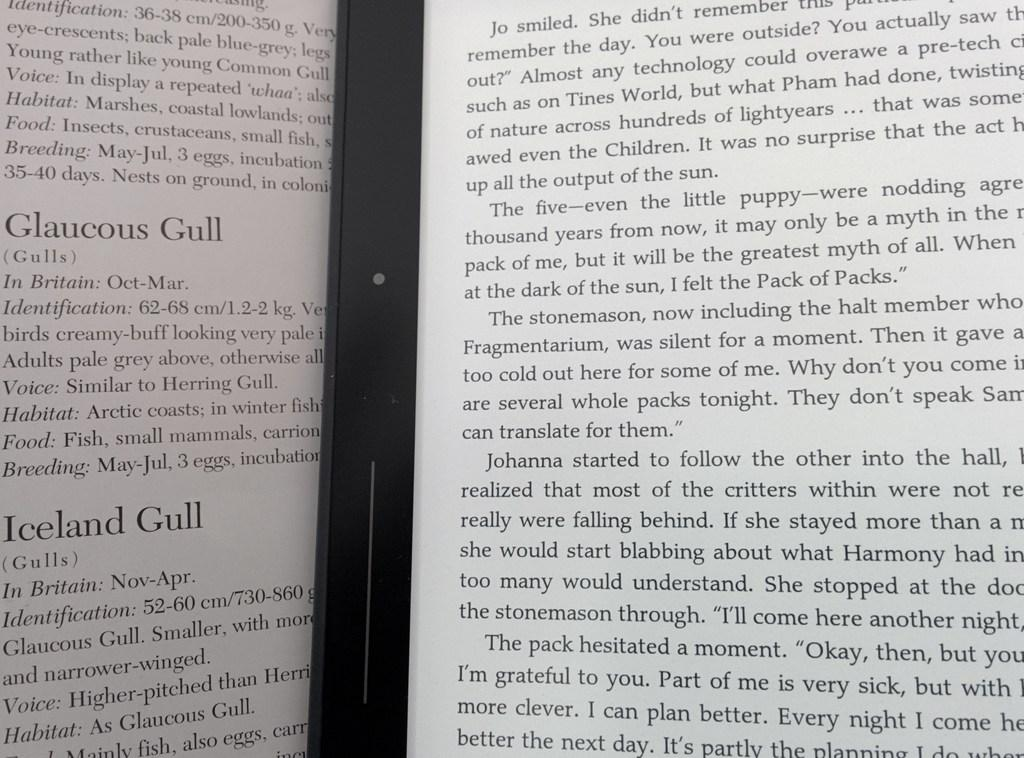Provide a one-sentence caption for the provided image. A book with a story under the title of Iceland Gull. 